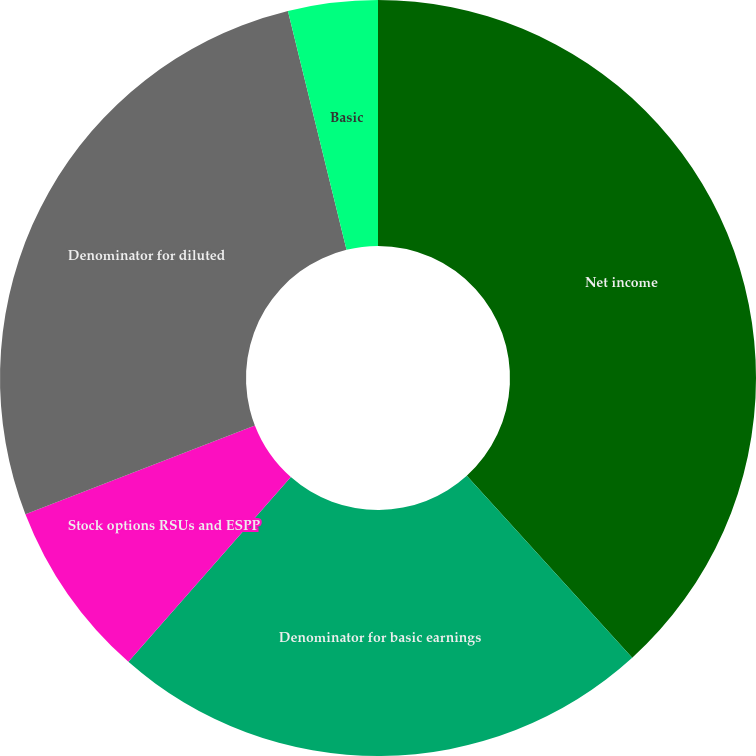<chart> <loc_0><loc_0><loc_500><loc_500><pie_chart><fcel>Net income<fcel>Denominator for basic earnings<fcel>Stock options RSUs and ESPP<fcel>Denominator for diluted<fcel>Basic<fcel>Diluted<nl><fcel>38.26%<fcel>23.22%<fcel>7.65%<fcel>27.04%<fcel>3.83%<fcel>0.0%<nl></chart> 